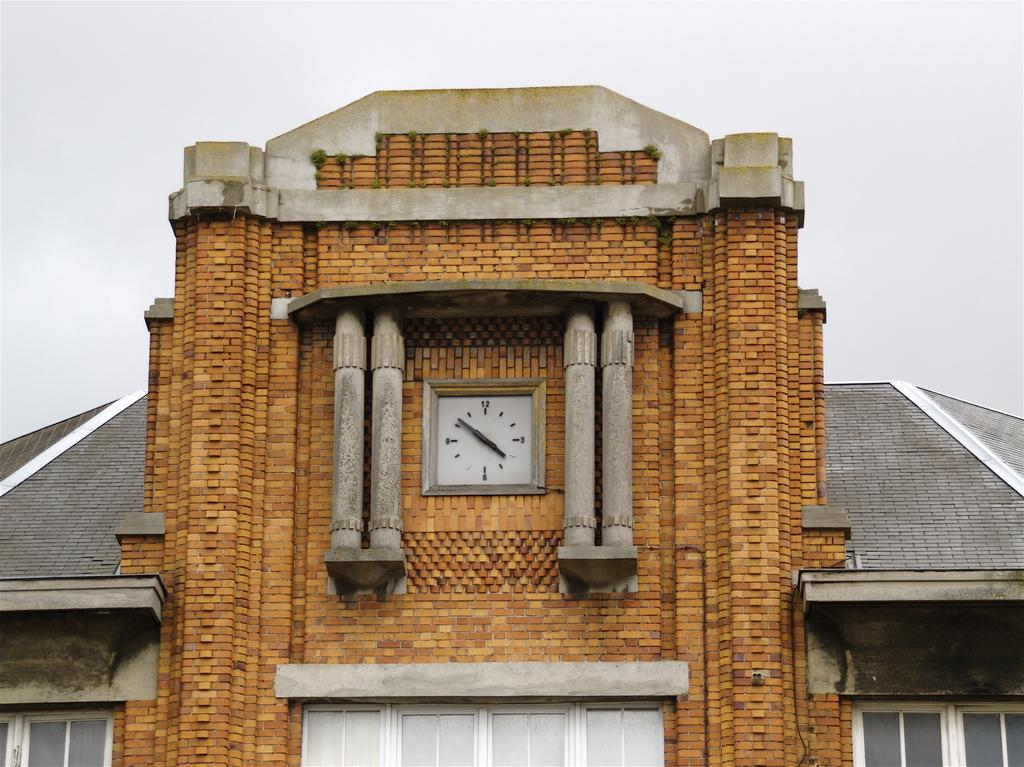What type of structure is shown in the image? The image depicts a building. What architectural features can be seen on the building? The building has windows and pillars. Is there any time-related object attached to the building? Yes, there is a wall clock attached to the building. What is visible on top of the building? The image shows a roof. What can be seen in the sky in the image? The sky is visible in the image. How many drains can be seen on the roof of the building in the image? There are no drains visible on the roof of the building in the image. What type of business is being conducted inside the building in the image? The image does not provide any information about the type of business being conducted inside the building. 